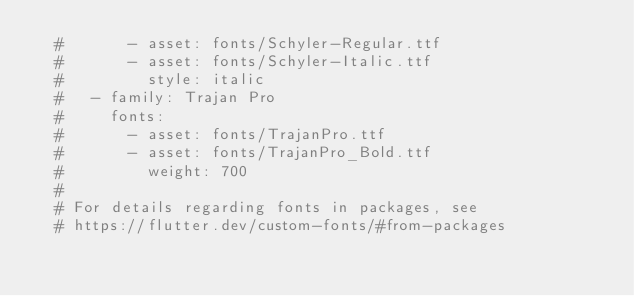<code> <loc_0><loc_0><loc_500><loc_500><_YAML_>  #       - asset: fonts/Schyler-Regular.ttf
  #       - asset: fonts/Schyler-Italic.ttf
  #         style: italic
  #   - family: Trajan Pro
  #     fonts:
  #       - asset: fonts/TrajanPro.ttf
  #       - asset: fonts/TrajanPro_Bold.ttf
  #         weight: 700
  #
  # For details regarding fonts in packages, see
  # https://flutter.dev/custom-fonts/#from-packages
</code> 